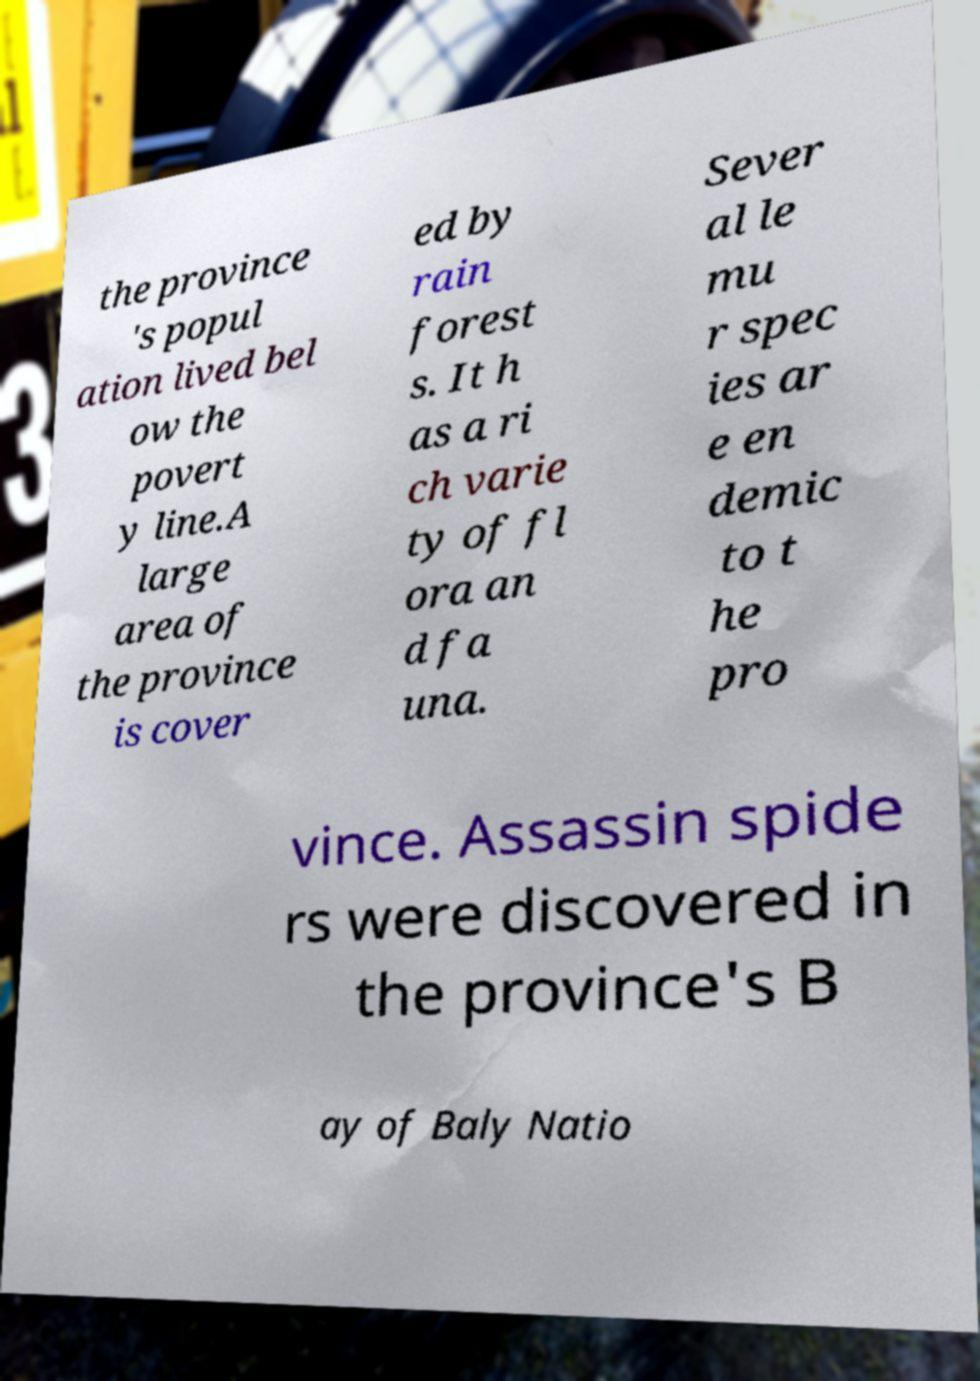Can you accurately transcribe the text from the provided image for me? the province 's popul ation lived bel ow the povert y line.A large area of the province is cover ed by rain forest s. It h as a ri ch varie ty of fl ora an d fa una. Sever al le mu r spec ies ar e en demic to t he pro vince. Assassin spide rs were discovered in the province's B ay of Baly Natio 